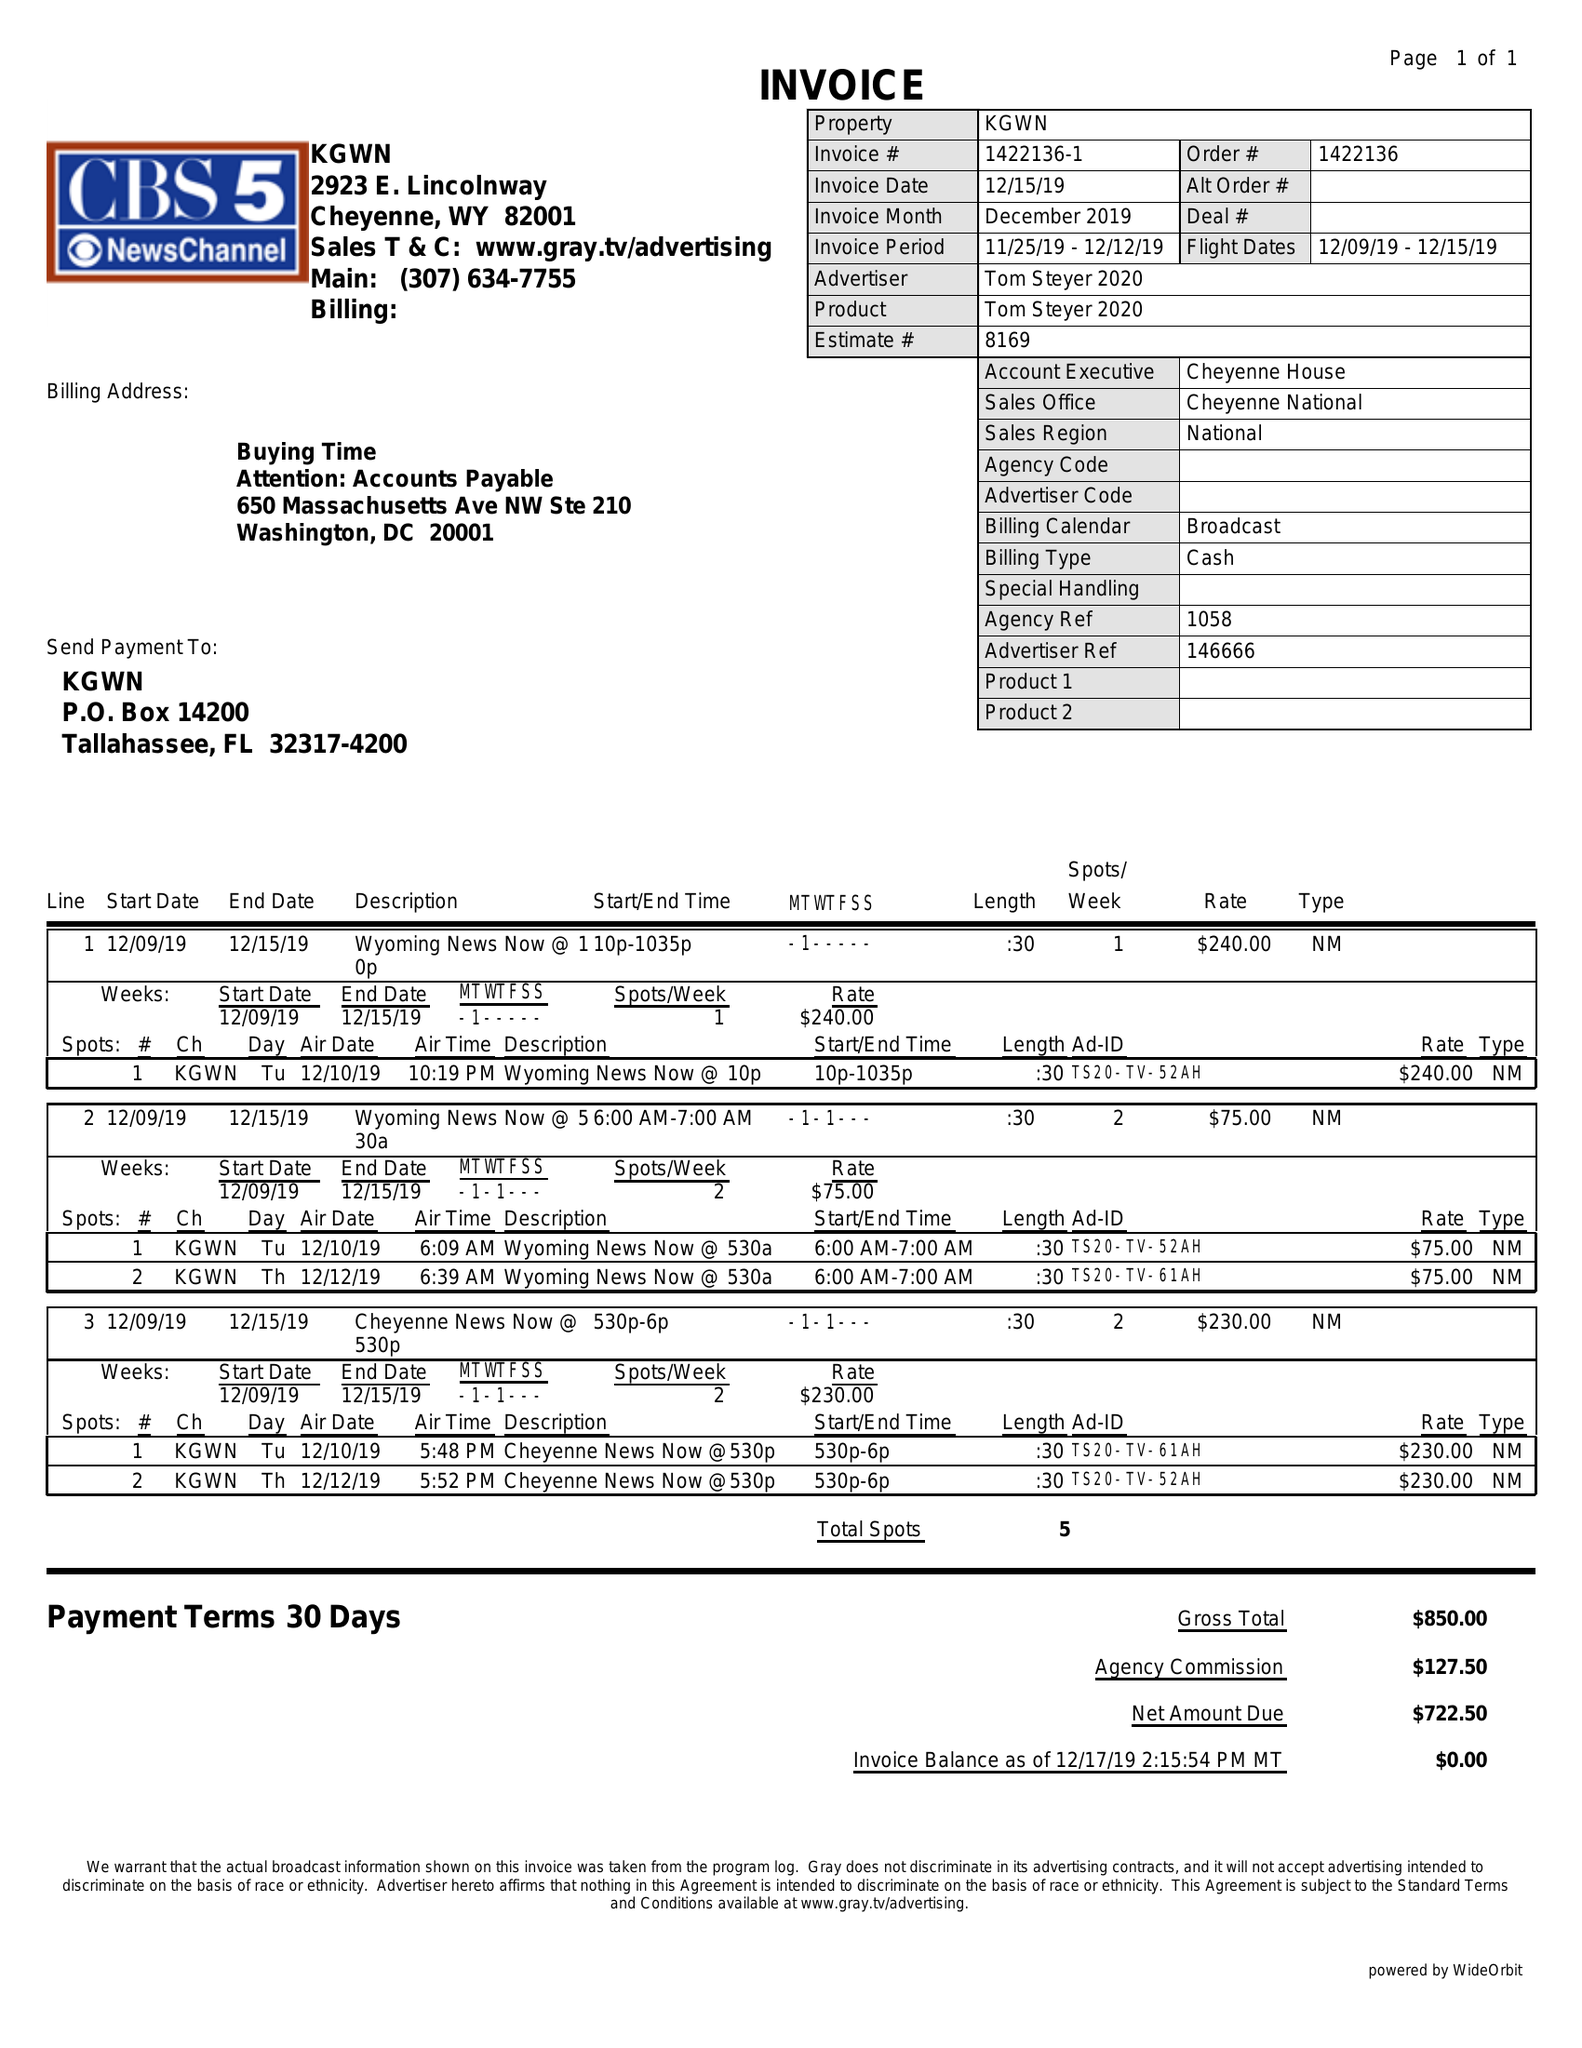What is the value for the contract_num?
Answer the question using a single word or phrase. 1422136 